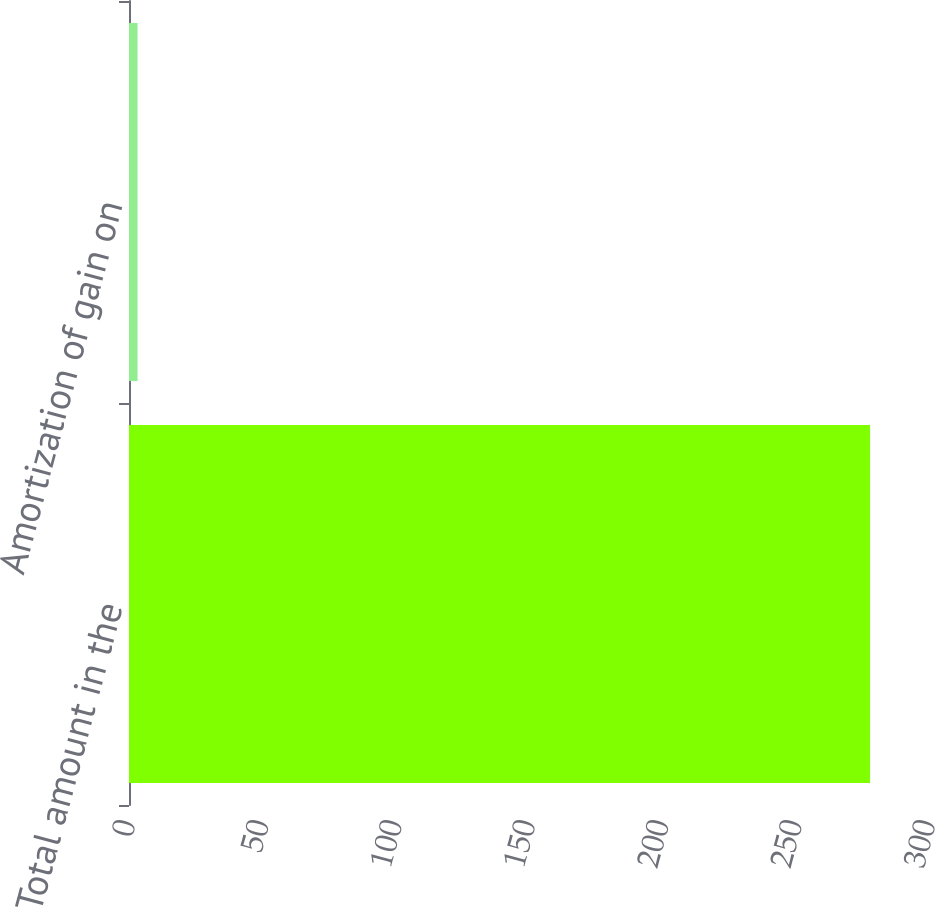Convert chart. <chart><loc_0><loc_0><loc_500><loc_500><bar_chart><fcel>Total amount in the<fcel>Amortization of gain on<nl><fcel>277.9<fcel>3.2<nl></chart> 